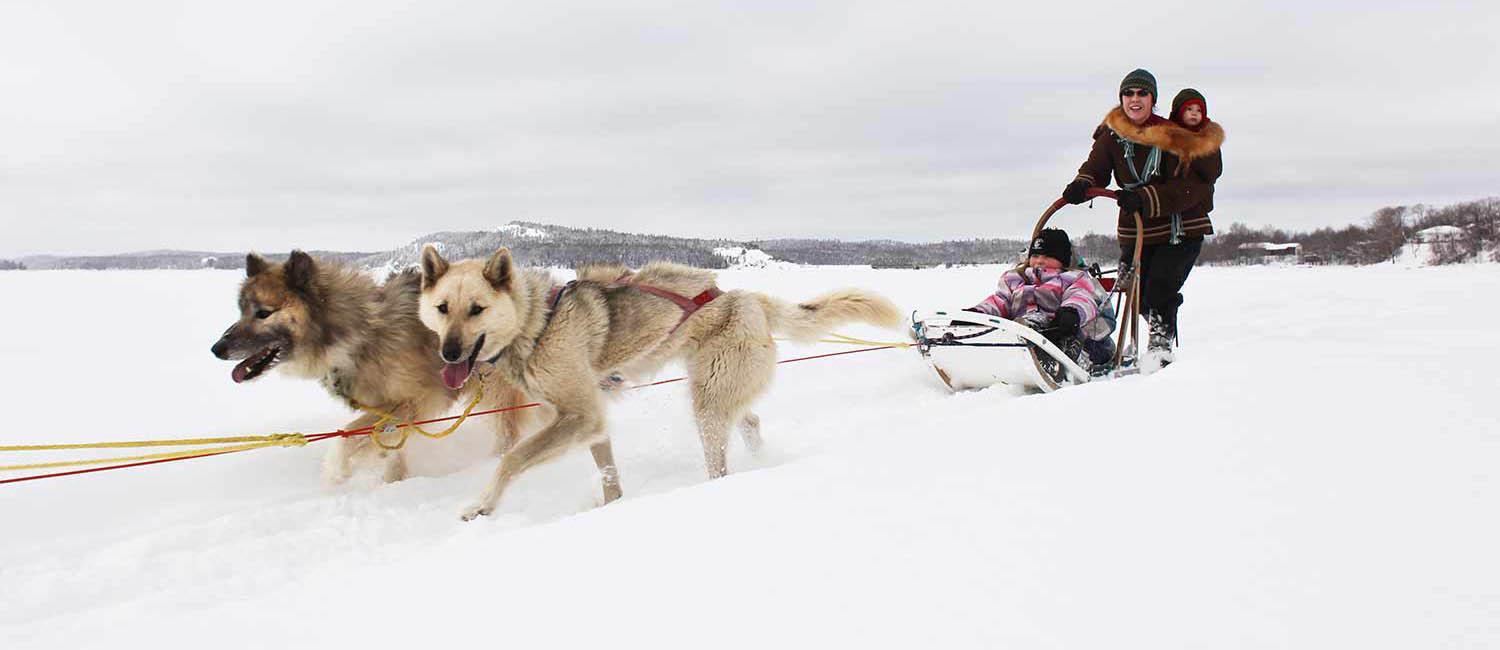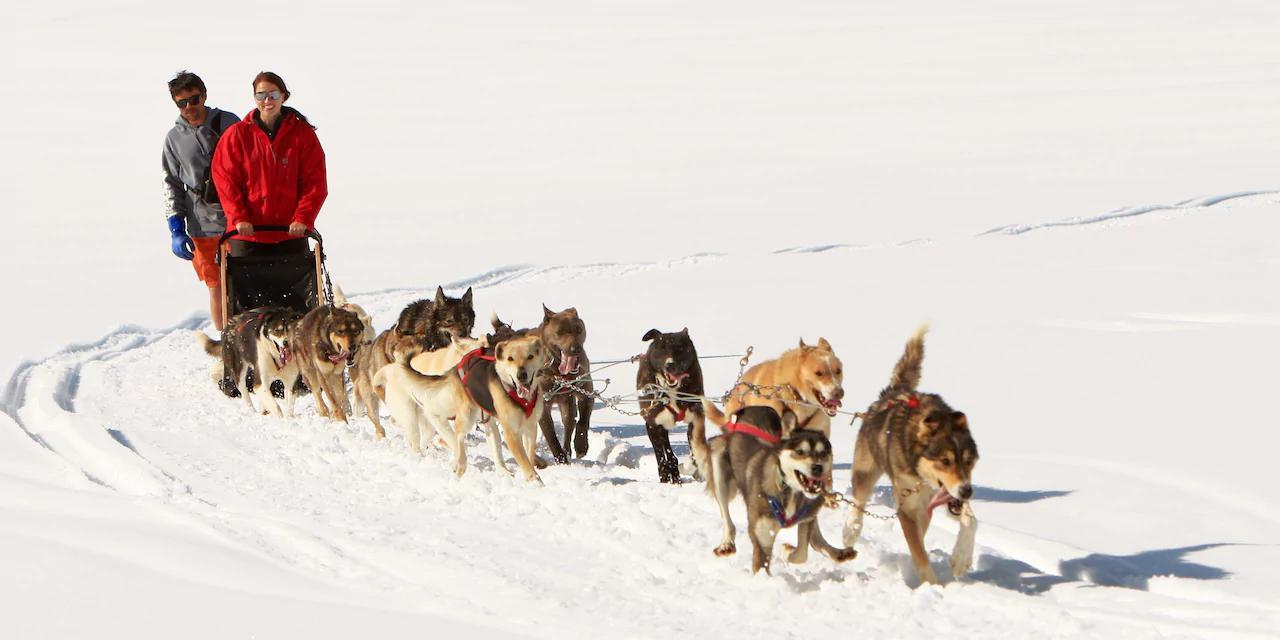The first image is the image on the left, the second image is the image on the right. Analyze the images presented: Is the assertion "The dog teams in the two images are each forward-facing, but headed in different directions." valid? Answer yes or no. Yes. The first image is the image on the left, the second image is the image on the right. For the images shown, is this caption "The leading dogs are blonde/gold, and black with a lighter muzzle." true? Answer yes or no. No. 